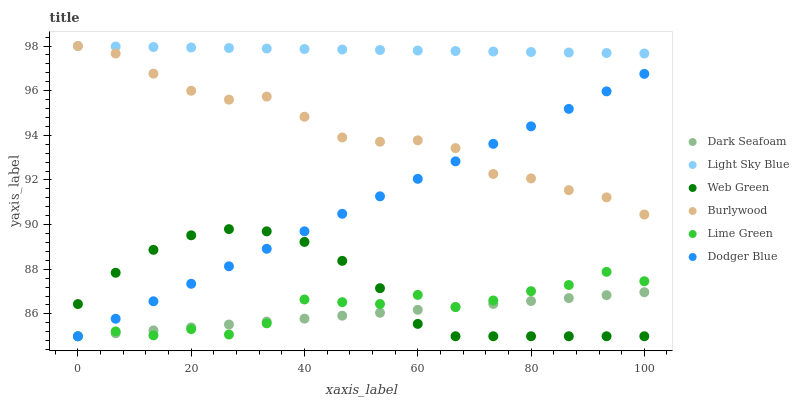Does Dark Seafoam have the minimum area under the curve?
Answer yes or no. Yes. Does Light Sky Blue have the maximum area under the curve?
Answer yes or no. Yes. Does Web Green have the minimum area under the curve?
Answer yes or no. No. Does Web Green have the maximum area under the curve?
Answer yes or no. No. Is Dark Seafoam the smoothest?
Answer yes or no. Yes. Is Lime Green the roughest?
Answer yes or no. Yes. Is Web Green the smoothest?
Answer yes or no. No. Is Web Green the roughest?
Answer yes or no. No. Does Web Green have the lowest value?
Answer yes or no. Yes. Does Light Sky Blue have the lowest value?
Answer yes or no. No. Does Light Sky Blue have the highest value?
Answer yes or no. Yes. Does Web Green have the highest value?
Answer yes or no. No. Is Web Green less than Burlywood?
Answer yes or no. Yes. Is Light Sky Blue greater than Web Green?
Answer yes or no. Yes. Does Web Green intersect Dodger Blue?
Answer yes or no. Yes. Is Web Green less than Dodger Blue?
Answer yes or no. No. Is Web Green greater than Dodger Blue?
Answer yes or no. No. Does Web Green intersect Burlywood?
Answer yes or no. No. 